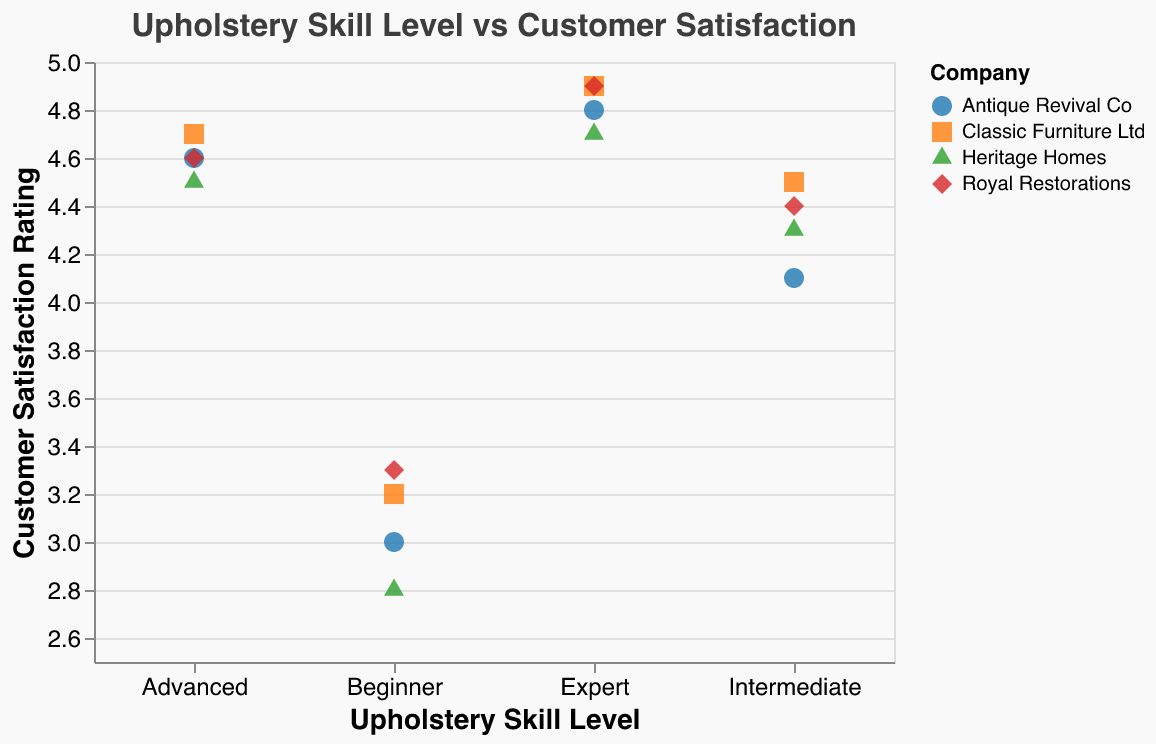What is the title of the figure? The title is usually found in a prominent position at the top of the chart. It gives a brief description of what the figure is about.
Answer: Upholstery Skill Level vs Customer Satisfaction How many data points are there in total? To find the total number of data points, count all the points shown on the scatter plot. Each point represents a unique combination of skill level, customer satisfaction, and company.
Answer: 16 Which company has the highest customer satisfaction rating at the Expert skill level? Locate the "Expert" skill level on the x-axis and find the data point with the highest y-axis value. Look at the color and shape associated with this point to determine the company.
Answer: Classic Furniture Ltd and Royal Restorations What is the overall trend between skill level and customer satisfaction? Observe the direction of the data points as they move from "Beginner" to "Expert" across the skill levels on the x-axis.
Answer: Customer satisfaction generally increases with skill level What's the average customer satisfaction rating for Intermediate skill level across all companies? Identify and sum all the data points for the "Intermediate" skill level, then divide by the number of companies.
Answer: (4.5 + 4.1 + 4.3 + 4.4) / 4 = 4.325 Which company shows the largest increase in customer satisfaction from Beginner to Expert skill level? Calculate the difference in customer satisfaction between "Expert" and "Beginner" for each company, and identify the company with the largest difference.
Answer: Heritage Homes (4.7 - 2.8 = 1.9) Which company has the lowest customer satisfaction rating at the Beginner skill level? Find the "Beginner" skill level on the x-axis and locate the data point with the lowest y-axis value. Check the color and shape to determine the company.
Answer: Heritage Homes Is there any company with equal customer satisfaction ratings at any two different skill levels? Examine the y-axis values for each company's data points across all skill levels to find any that match exactly.
Answer: No How does the customer satisfaction rating for Royal Restorations at the Intermediate skill level compare to Antique Revival Co at the Advanced skill level? Identify the data points corresponding to Royal Restorations at "Intermediate" and Antique Revival Co at "Advanced". Compare the y-axis values of these points.
Answer: Royal Restorations (4.4) is less than Antique Revival Co (4.6) 